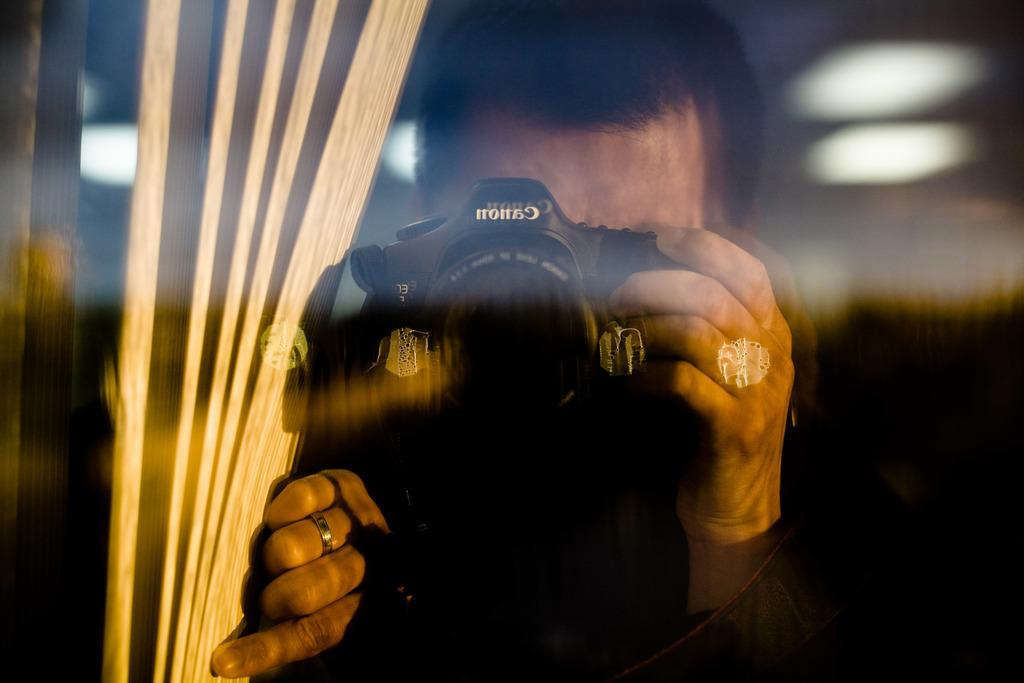What is the main subject of the image? There is a person in the image. What is the person doing in the image? The person is taking pictures with a camera. What can be seen beside the person in the image? There is a curtain beside the person. How would you describe the background of the image? The background of the image is blurred. What type of owl can be seen perched on the camera in the image? There is no owl present in the image; the person is taking pictures with a camera. What is the weather like in the image? The provided facts do not mention the weather, so it cannot be determined from the image. 